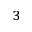<formula> <loc_0><loc_0><loc_500><loc_500>{ _ { 3 } }</formula> 